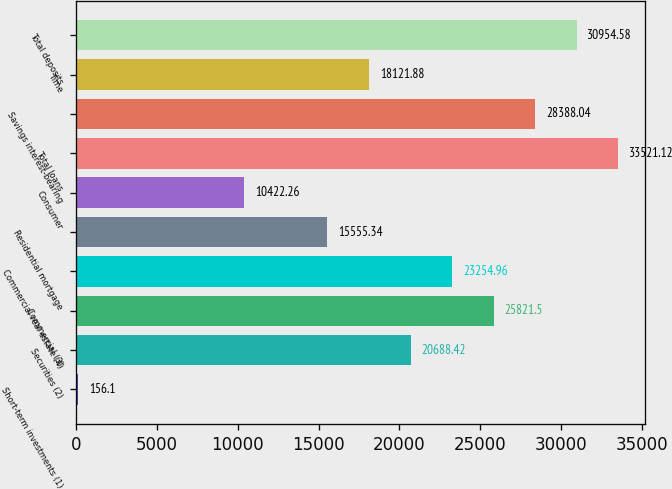<chart> <loc_0><loc_0><loc_500><loc_500><bar_chart><fcel>Short-term investments (1)<fcel>Securities (2)<fcel>Commercial (3)<fcel>Commercial real estate (4)<fcel>Residential mortgage<fcel>Consumer<fcel>Total loans<fcel>Savings interest-bearing<fcel>Time<fcel>Total deposits<nl><fcel>156.1<fcel>20688.4<fcel>25821.5<fcel>23255<fcel>15555.3<fcel>10422.3<fcel>33521.1<fcel>28388<fcel>18121.9<fcel>30954.6<nl></chart> 